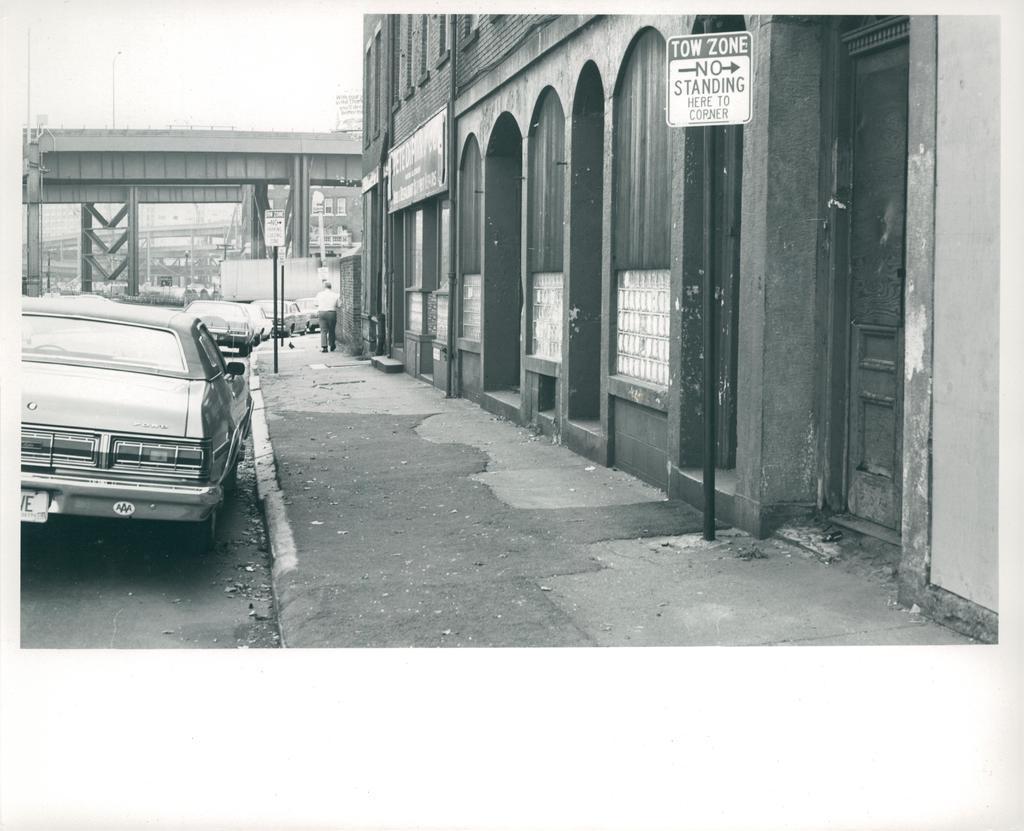Can you describe this image briefly? This is a black and white image. In the center of the image there is a road on which there are vehicles. In the background of the image there is a bridge. To the right side of the image there is a building. There are sign boards. There is a pavement. 